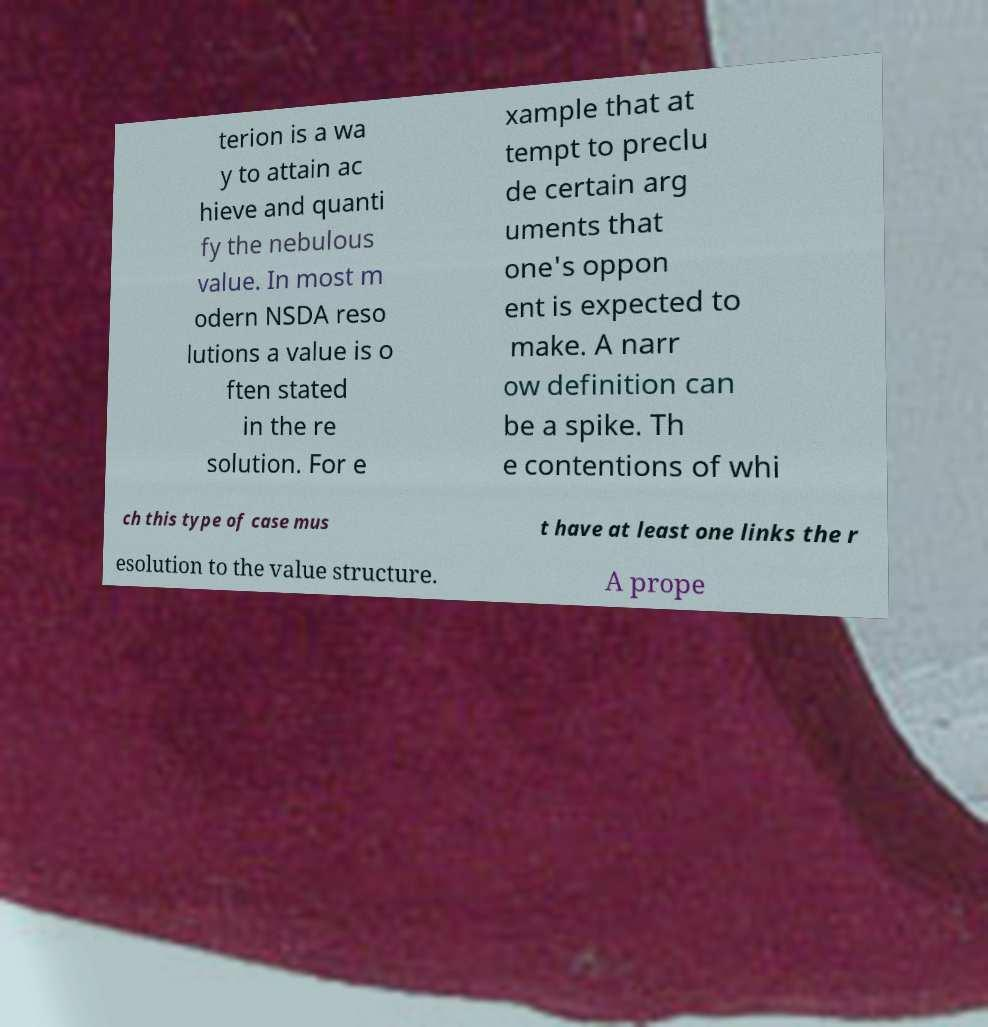I need the written content from this picture converted into text. Can you do that? terion is a wa y to attain ac hieve and quanti fy the nebulous value. In most m odern NSDA reso lutions a value is o ften stated in the re solution. For e xample that at tempt to preclu de certain arg uments that one's oppon ent is expected to make. A narr ow definition can be a spike. Th e contentions of whi ch this type of case mus t have at least one links the r esolution to the value structure. A prope 